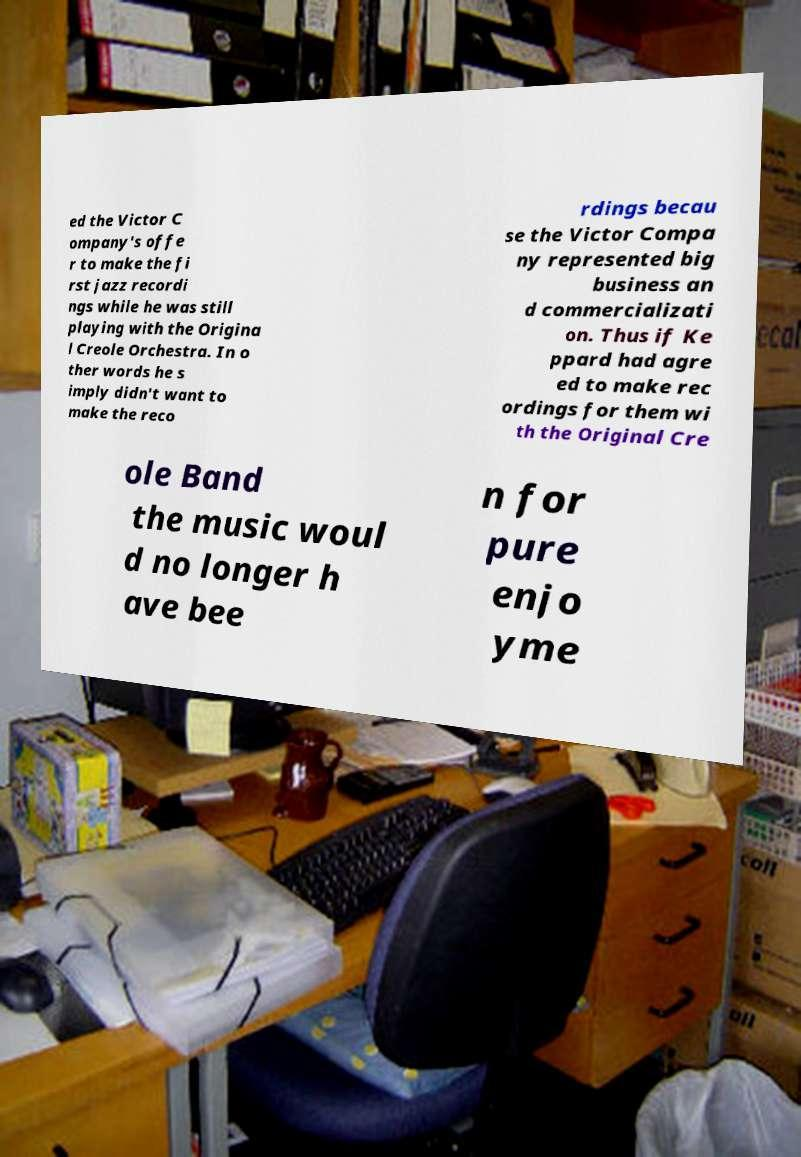Could you assist in decoding the text presented in this image and type it out clearly? ed the Victor C ompany's offe r to make the fi rst jazz recordi ngs while he was still playing with the Origina l Creole Orchestra. In o ther words he s imply didn't want to make the reco rdings becau se the Victor Compa ny represented big business an d commercializati on. Thus if Ke ppard had agre ed to make rec ordings for them wi th the Original Cre ole Band the music woul d no longer h ave bee n for pure enjo yme 